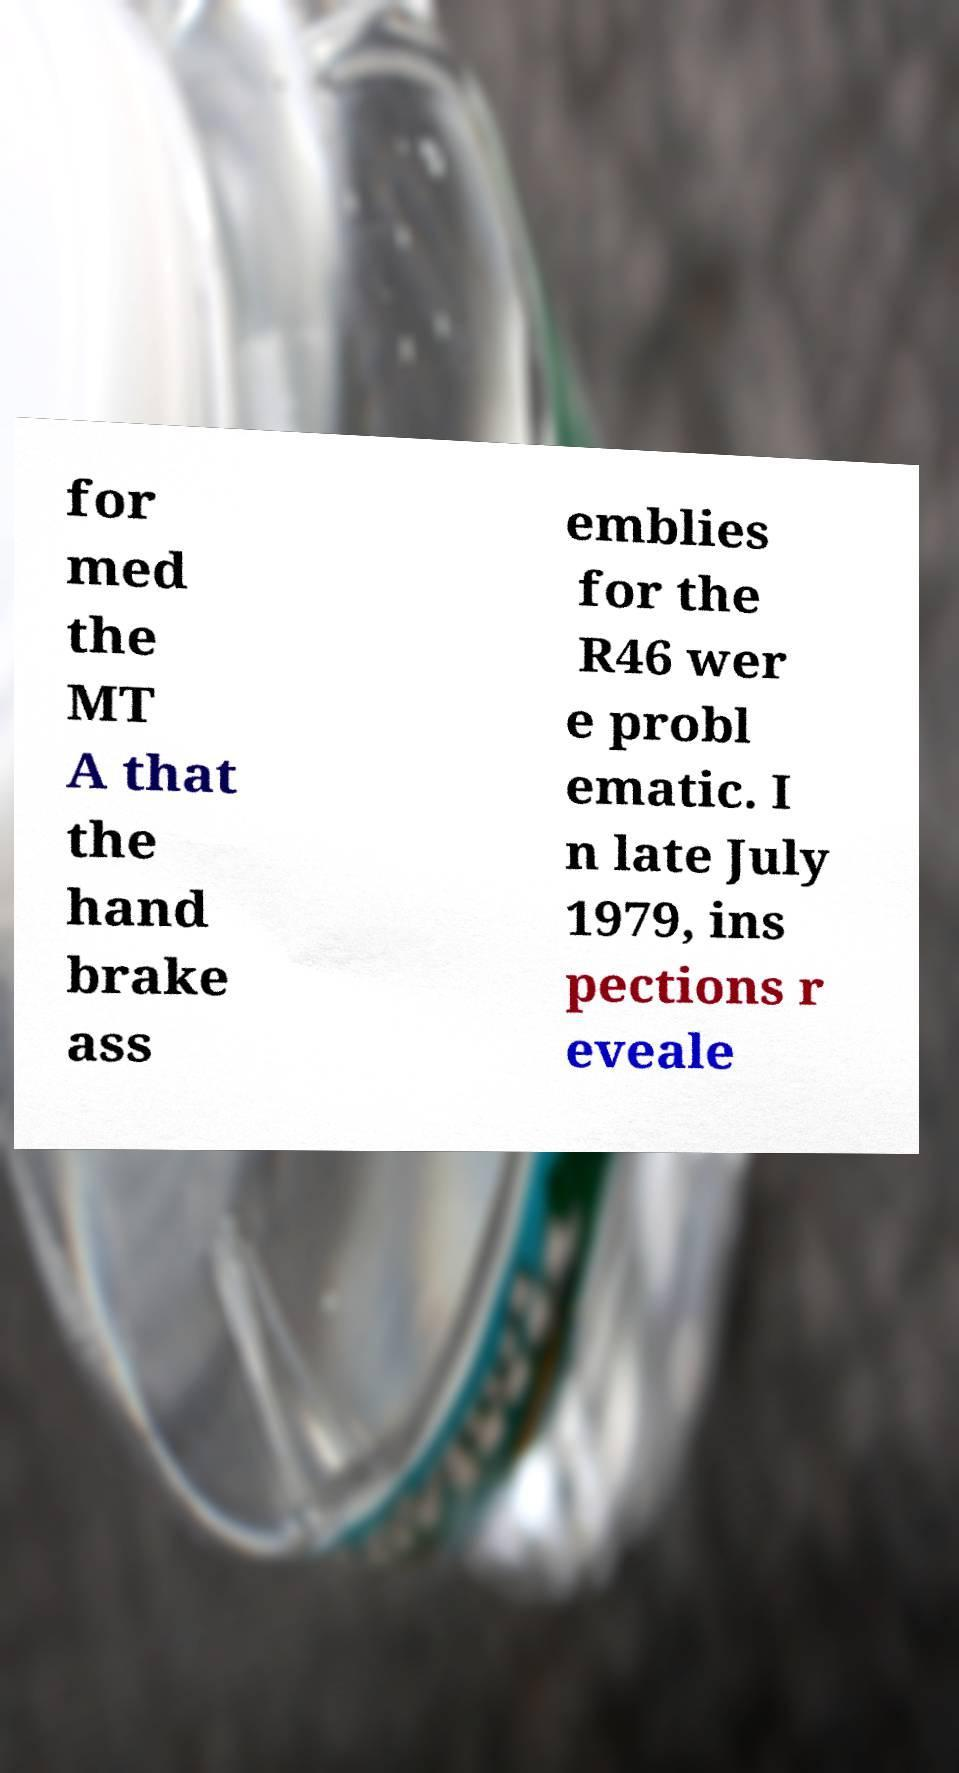Can you accurately transcribe the text from the provided image for me? for med the MT A that the hand brake ass emblies for the R46 wer e probl ematic. I n late July 1979, ins pections r eveale 